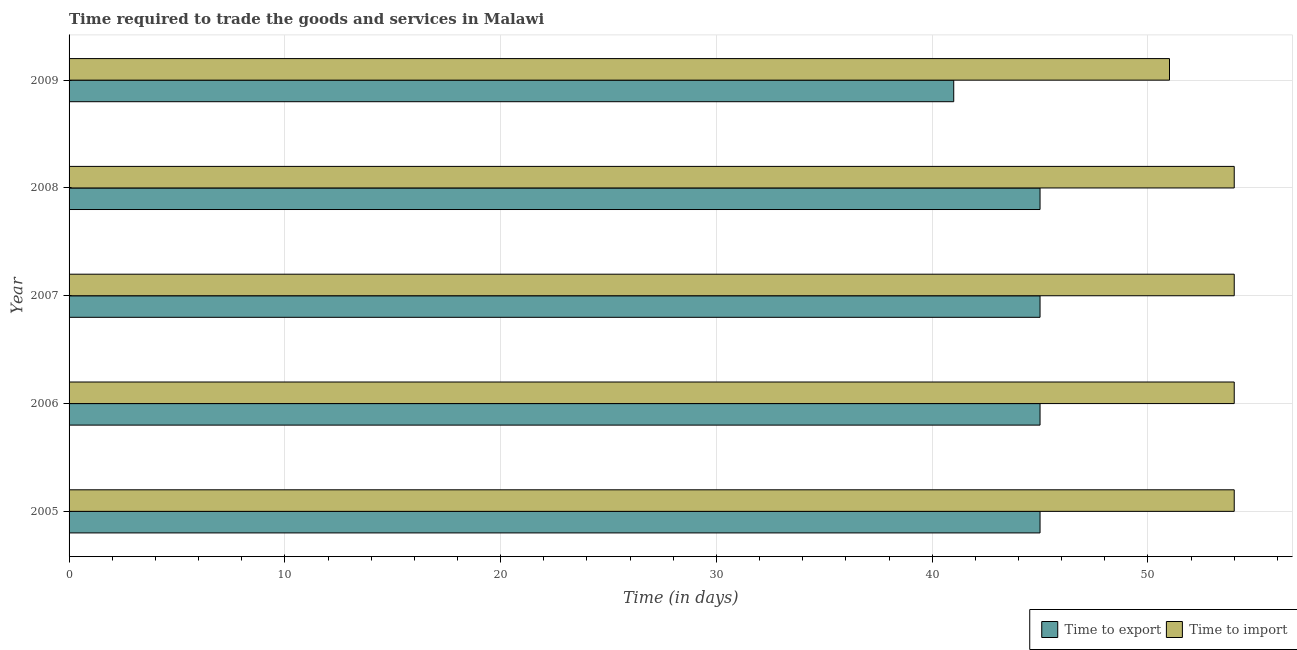How many different coloured bars are there?
Ensure brevity in your answer.  2. How many groups of bars are there?
Offer a terse response. 5. Are the number of bars on each tick of the Y-axis equal?
Offer a terse response. Yes. What is the time to import in 2007?
Ensure brevity in your answer.  54. Across all years, what is the maximum time to import?
Your answer should be compact. 54. Across all years, what is the minimum time to import?
Keep it short and to the point. 51. In which year was the time to import minimum?
Your answer should be compact. 2009. What is the total time to export in the graph?
Your answer should be very brief. 221. What is the difference between the time to import in 2006 and the time to export in 2005?
Offer a very short reply. 9. What is the average time to export per year?
Give a very brief answer. 44.2. In the year 2008, what is the difference between the time to import and time to export?
Give a very brief answer. 9. Is the time to export in 2005 less than that in 2009?
Provide a succinct answer. No. What is the difference between the highest and the second highest time to export?
Offer a very short reply. 0. What is the difference between the highest and the lowest time to export?
Make the answer very short. 4. In how many years, is the time to export greater than the average time to export taken over all years?
Your answer should be very brief. 4. Is the sum of the time to import in 2006 and 2009 greater than the maximum time to export across all years?
Keep it short and to the point. Yes. What does the 1st bar from the top in 2006 represents?
Give a very brief answer. Time to import. What does the 1st bar from the bottom in 2005 represents?
Provide a succinct answer. Time to export. How many bars are there?
Provide a succinct answer. 10. Are all the bars in the graph horizontal?
Provide a succinct answer. Yes. Does the graph contain any zero values?
Keep it short and to the point. No. How many legend labels are there?
Offer a terse response. 2. What is the title of the graph?
Offer a very short reply. Time required to trade the goods and services in Malawi. What is the label or title of the X-axis?
Give a very brief answer. Time (in days). What is the label or title of the Y-axis?
Ensure brevity in your answer.  Year. What is the Time (in days) in Time to export in 2005?
Offer a terse response. 45. What is the Time (in days) in Time to import in 2005?
Your answer should be very brief. 54. What is the Time (in days) of Time to export in 2006?
Keep it short and to the point. 45. What is the Time (in days) in Time to import in 2006?
Give a very brief answer. 54. What is the Time (in days) of Time to import in 2007?
Keep it short and to the point. 54. Across all years, what is the maximum Time (in days) in Time to import?
Make the answer very short. 54. Across all years, what is the minimum Time (in days) of Time to export?
Offer a very short reply. 41. What is the total Time (in days) of Time to export in the graph?
Provide a short and direct response. 221. What is the total Time (in days) in Time to import in the graph?
Ensure brevity in your answer.  267. What is the difference between the Time (in days) in Time to export in 2005 and that in 2006?
Ensure brevity in your answer.  0. What is the difference between the Time (in days) in Time to export in 2005 and that in 2009?
Your answer should be very brief. 4. What is the difference between the Time (in days) in Time to import in 2005 and that in 2009?
Your response must be concise. 3. What is the difference between the Time (in days) of Time to import in 2006 and that in 2007?
Provide a short and direct response. 0. What is the difference between the Time (in days) in Time to export in 2007 and that in 2008?
Offer a very short reply. 0. What is the difference between the Time (in days) of Time to export in 2007 and that in 2009?
Provide a short and direct response. 4. What is the difference between the Time (in days) of Time to import in 2007 and that in 2009?
Ensure brevity in your answer.  3. What is the difference between the Time (in days) of Time to export in 2008 and that in 2009?
Keep it short and to the point. 4. What is the difference between the Time (in days) of Time to import in 2008 and that in 2009?
Your answer should be compact. 3. What is the difference between the Time (in days) in Time to export in 2006 and the Time (in days) in Time to import in 2008?
Make the answer very short. -9. What is the difference between the Time (in days) of Time to export in 2006 and the Time (in days) of Time to import in 2009?
Offer a very short reply. -6. What is the difference between the Time (in days) in Time to export in 2007 and the Time (in days) in Time to import in 2009?
Provide a short and direct response. -6. What is the difference between the Time (in days) of Time to export in 2008 and the Time (in days) of Time to import in 2009?
Offer a terse response. -6. What is the average Time (in days) of Time to export per year?
Make the answer very short. 44.2. What is the average Time (in days) in Time to import per year?
Give a very brief answer. 53.4. What is the ratio of the Time (in days) in Time to import in 2005 to that in 2006?
Your answer should be compact. 1. What is the ratio of the Time (in days) in Time to export in 2005 to that in 2007?
Give a very brief answer. 1. What is the ratio of the Time (in days) in Time to import in 2005 to that in 2007?
Make the answer very short. 1. What is the ratio of the Time (in days) of Time to export in 2005 to that in 2009?
Provide a short and direct response. 1.1. What is the ratio of the Time (in days) of Time to import in 2005 to that in 2009?
Provide a succinct answer. 1.06. What is the ratio of the Time (in days) in Time to import in 2006 to that in 2008?
Keep it short and to the point. 1. What is the ratio of the Time (in days) in Time to export in 2006 to that in 2009?
Provide a short and direct response. 1.1. What is the ratio of the Time (in days) of Time to import in 2006 to that in 2009?
Your response must be concise. 1.06. What is the ratio of the Time (in days) of Time to export in 2007 to that in 2008?
Your answer should be very brief. 1. What is the ratio of the Time (in days) in Time to import in 2007 to that in 2008?
Make the answer very short. 1. What is the ratio of the Time (in days) in Time to export in 2007 to that in 2009?
Offer a very short reply. 1.1. What is the ratio of the Time (in days) of Time to import in 2007 to that in 2009?
Your response must be concise. 1.06. What is the ratio of the Time (in days) in Time to export in 2008 to that in 2009?
Your answer should be very brief. 1.1. What is the ratio of the Time (in days) of Time to import in 2008 to that in 2009?
Give a very brief answer. 1.06. What is the difference between the highest and the lowest Time (in days) in Time to export?
Keep it short and to the point. 4. What is the difference between the highest and the lowest Time (in days) in Time to import?
Ensure brevity in your answer.  3. 